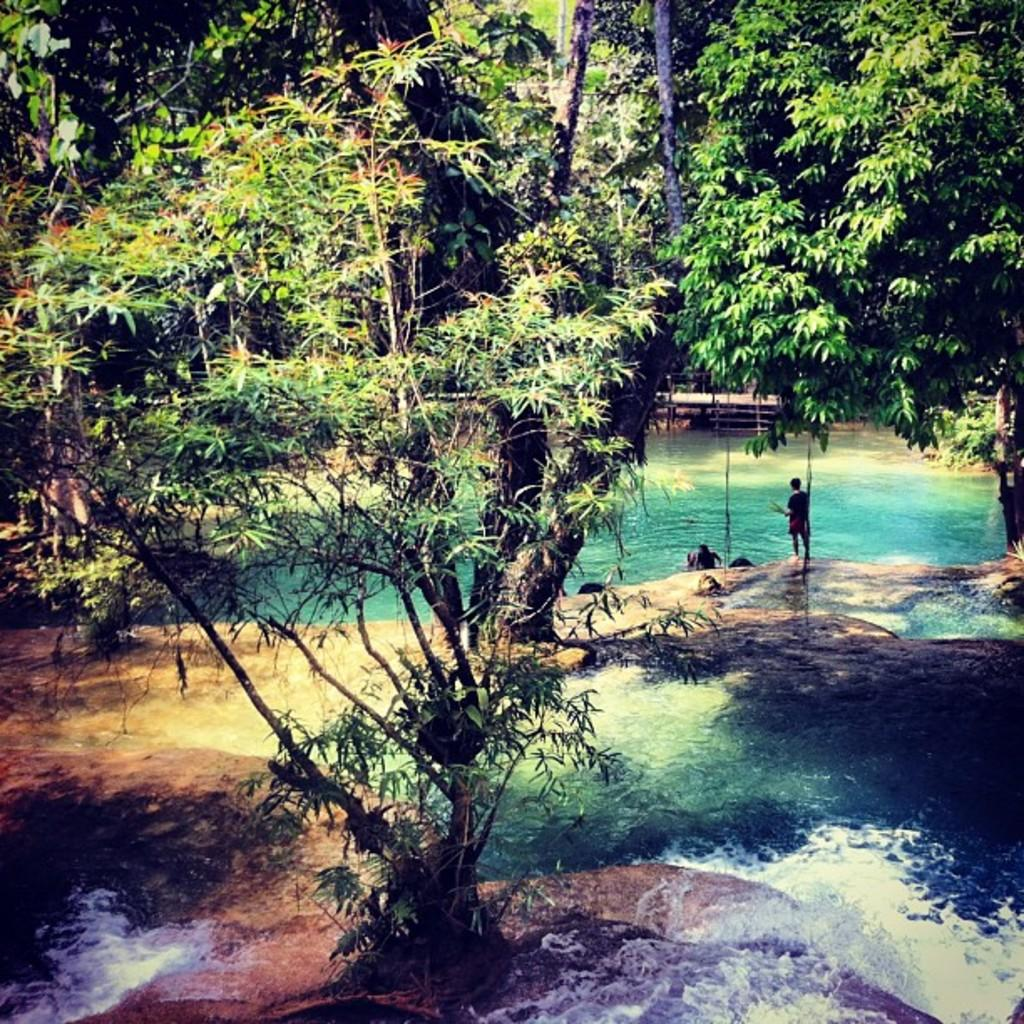What type of natural environment is depicted in the image? There are many trees in the image, suggesting a forest or wooded area. What else can be seen in the image besides trees? There is water visible in the image, as well as rocks. Are there any human elements in the image? Yes, there are people in the image. What type of potato can be seen growing near the water in the image? There is no potato present in the image; the focus is on trees, water, rocks, and people. 